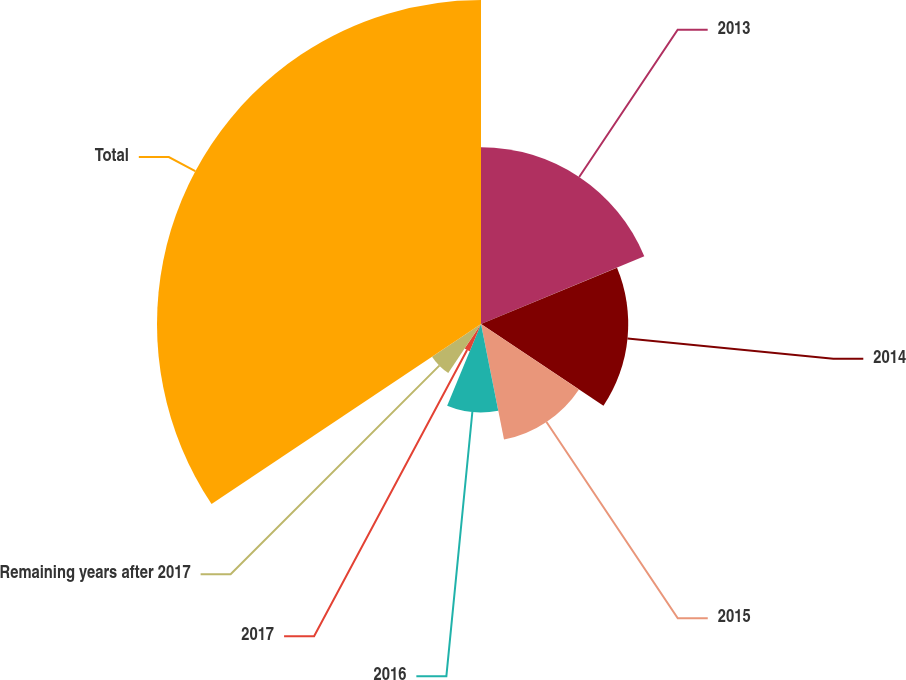<chart> <loc_0><loc_0><loc_500><loc_500><pie_chart><fcel>2013<fcel>2014<fcel>2015<fcel>2016<fcel>2017<fcel>Remaining years after 2017<fcel>Total<nl><fcel>18.75%<fcel>15.62%<fcel>12.5%<fcel>9.38%<fcel>3.13%<fcel>6.25%<fcel>34.37%<nl></chart> 